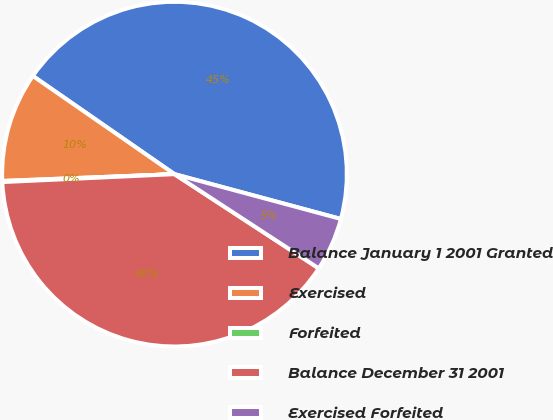Convert chart to OTSL. <chart><loc_0><loc_0><loc_500><loc_500><pie_chart><fcel>Balance January 1 2001 Granted<fcel>Exercised<fcel>Forfeited<fcel>Balance December 31 2001<fcel>Exercised Forfeited<nl><fcel>44.54%<fcel>10.28%<fcel>0.1%<fcel>40.06%<fcel>5.02%<nl></chart> 